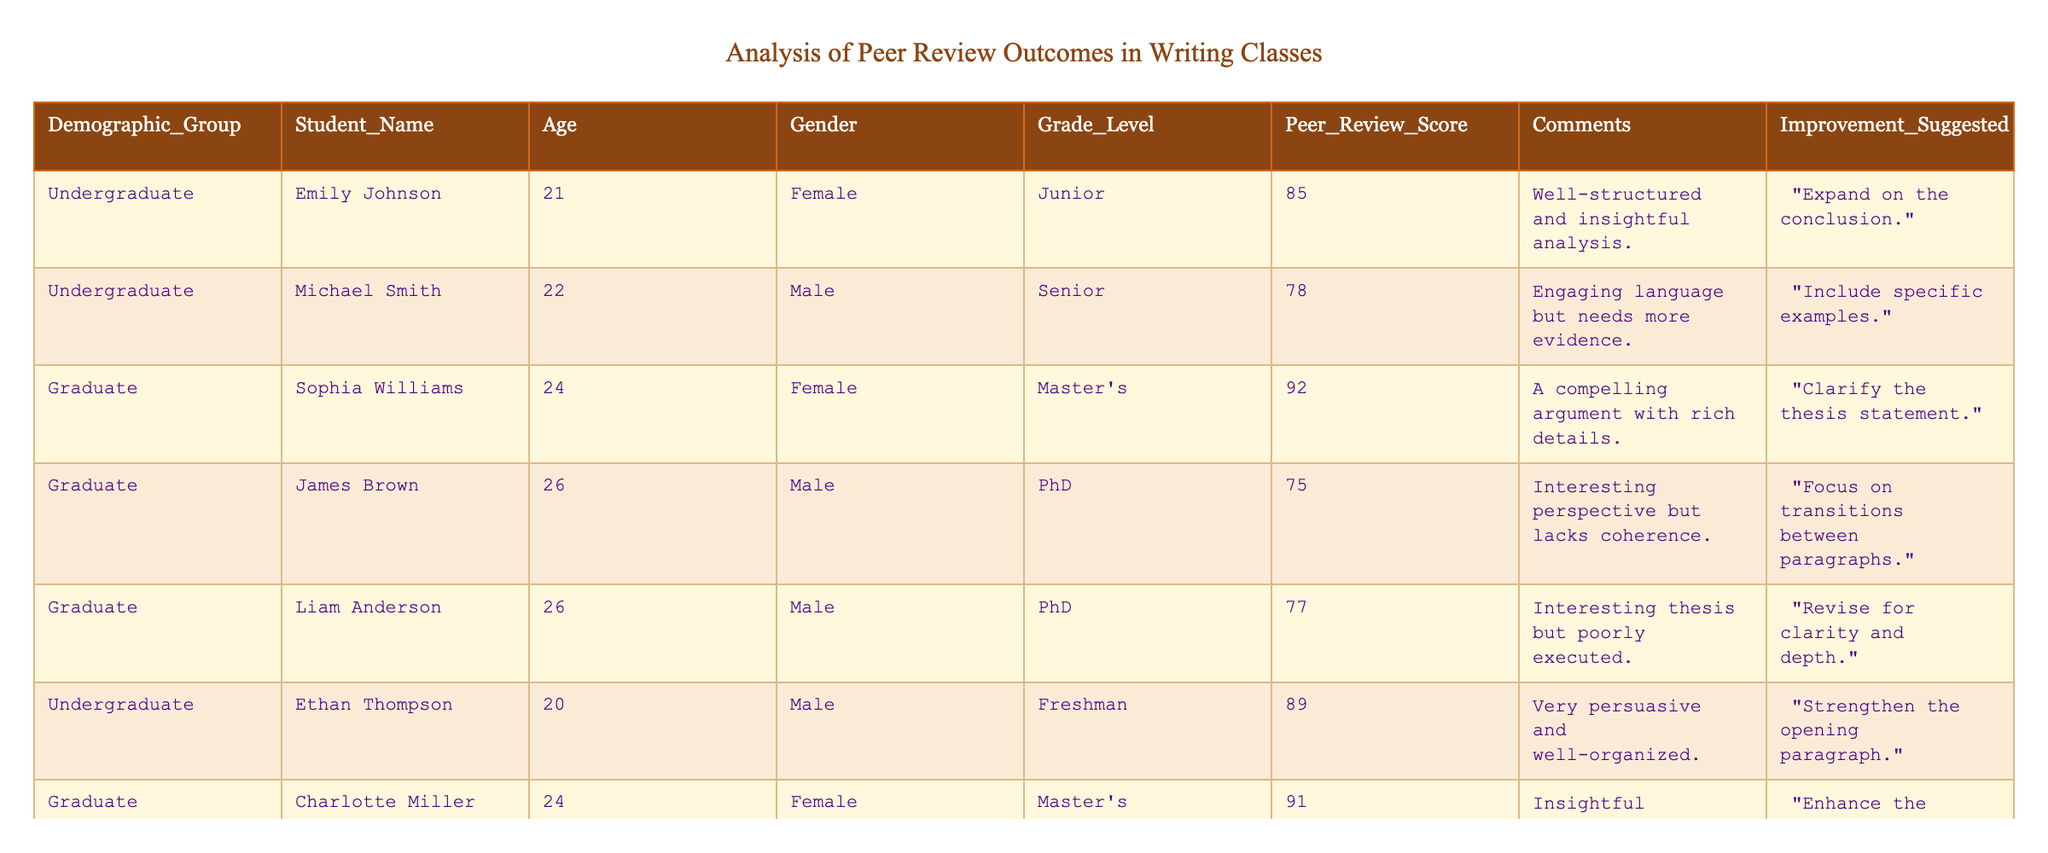What is the highest peer review score among the students? By examining the 'Peer Review Score' column, the scores are 85, 78, 92, 75, 77, 89, 91, and 86. The highest score is 92, attributed to Sophia Williams.
Answer: 92 Which demographic group received the lowest peer review score? Looking at the 'Demographic Group' along with their respective 'Peer Review Score', we can see that James Brown from the Graduate demographic received the lowest score of 75.
Answer: Graduate How many students are enrolled in the Master's program, and what is their average peer review score? There are 2 students from the Master's program: Sophia Williams (92) and Charlotte Miller (91). Their average peer review score is calculated by (92 + 91) / 2 = 91.5.
Answer: 91.5 Did any female students receive a peer review score above 90? By checking the 'Gender' and 'Peer Review Score', we find that both Sophia Williams (92) and Charlotte Miller (91) are female and received scores above 90. Thus, the answer is yes.
Answer: Yes What is the average peer review score for undergraduate students only? The undergraduate students' scores are 85, 78, 89, and 86. To find the average, we sum these scores: (85 + 78 + 89 + 86) = 338, and then divide by the number of undergraduate students, which is 4. The average score is 338 / 4 = 84.5.
Answer: 84.5 How many students suggested improving the clarity of their arguments? Upon reviewing the 'Improvement Suggested' column, we need to identify the comments suggesting clarity improvements. James Brown and Liam Anderson suggested revising for clarity, making it a total of 2 students.
Answer: 2 What is the difference between the highest and lowest peer review scores among graduate students? The highest score among graduate students is Sophia Williams with 92, and the lowest score is James Brown with 75. The difference is calculated as 92 - 75 = 17.
Answer: 17 Which student suggested strengthening the opening paragraph, and what was their peer review score? Looking at the 'Comments' for each student, Ethan Thompson suggested strengthening the opening paragraph, and their peer review score is 89.
Answer: Ethan Thompson, 89 How many students provided comments including suggestions for their conclusions? By examining the comments, Emily Johnson and Charlotte Miller both suggested improvements to their conclusions, totaling 2 students.
Answer: 2 What is the average age of the students in the table? The ages of the students are: 21, 22, 24, 26, 26, 20, 24, and 19. The sum of the ages is 21 + 22 + 24 + 26 + 26 + 20 + 24 + 19 = 192. There are 8 students, so the average age is 192 / 8 = 24.
Answer: 24 